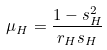<formula> <loc_0><loc_0><loc_500><loc_500>\mu _ { H } = \frac { 1 - s _ { H } ^ { 2 } } { r _ { H } s _ { H } }</formula> 